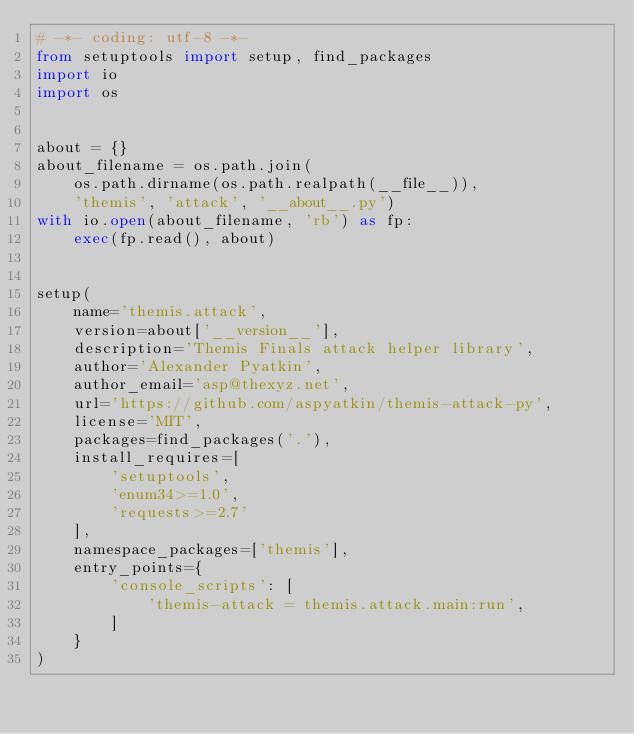Convert code to text. <code><loc_0><loc_0><loc_500><loc_500><_Python_># -*- coding: utf-8 -*-
from setuptools import setup, find_packages
import io
import os


about = {}
about_filename = os.path.join(
    os.path.dirname(os.path.realpath(__file__)),
    'themis', 'attack', '__about__.py')
with io.open(about_filename, 'rb') as fp:
    exec(fp.read(), about)


setup(
    name='themis.attack',
    version=about['__version__'],
    description='Themis Finals attack helper library',
    author='Alexander Pyatkin',
    author_email='asp@thexyz.net',
    url='https://github.com/aspyatkin/themis-attack-py',
    license='MIT',
    packages=find_packages('.'),
    install_requires=[
        'setuptools',
        'enum34>=1.0',
        'requests>=2.7'
    ],
    namespace_packages=['themis'],
    entry_points={
        'console_scripts': [
            'themis-attack = themis.attack.main:run',
        ]
    }
)
</code> 